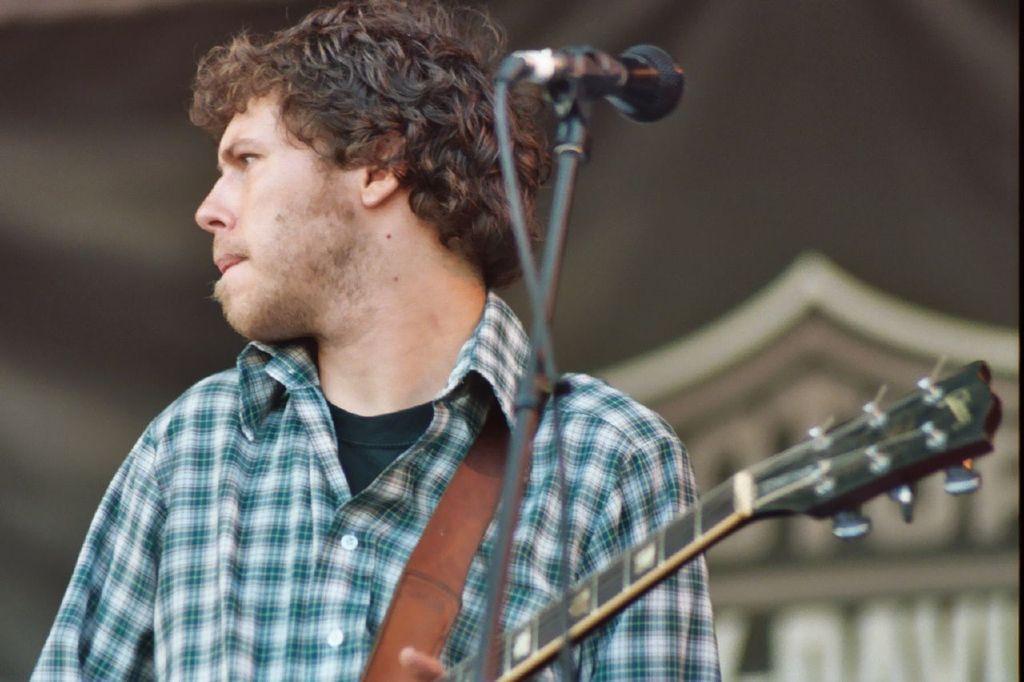Can you describe this image briefly? This is the picture of a man in checks shirt holding the music instrument. In front of the man there is a microphone with stand. Background of the man is blur. 